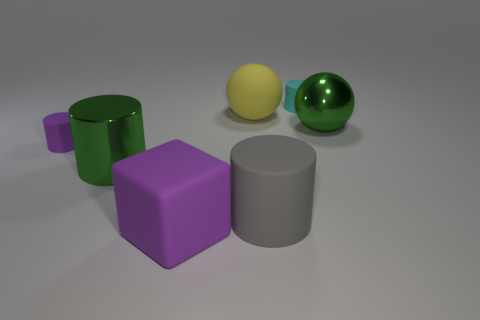Are there any other things of the same color as the large block?
Offer a very short reply. Yes. There is a big green object that is left of the green metallic object that is on the right side of the green object in front of the small purple rubber cylinder; what is its shape?
Make the answer very short. Cylinder. Are there more gray matte cylinders than small cyan metal things?
Your response must be concise. Yes. Is there a tiny red cube?
Give a very brief answer. No. How many things are large cylinders on the right side of the large green cylinder or matte things that are in front of the matte sphere?
Provide a succinct answer. 3. Does the metal sphere have the same color as the shiny cylinder?
Offer a very short reply. Yes. Are there fewer gray cylinders than small purple matte spheres?
Make the answer very short. No. There is a big yellow object; are there any large balls in front of it?
Offer a terse response. Yes. Do the block and the big green cylinder have the same material?
Offer a terse response. No. The other large thing that is the same shape as the big yellow object is what color?
Your answer should be compact. Green. 